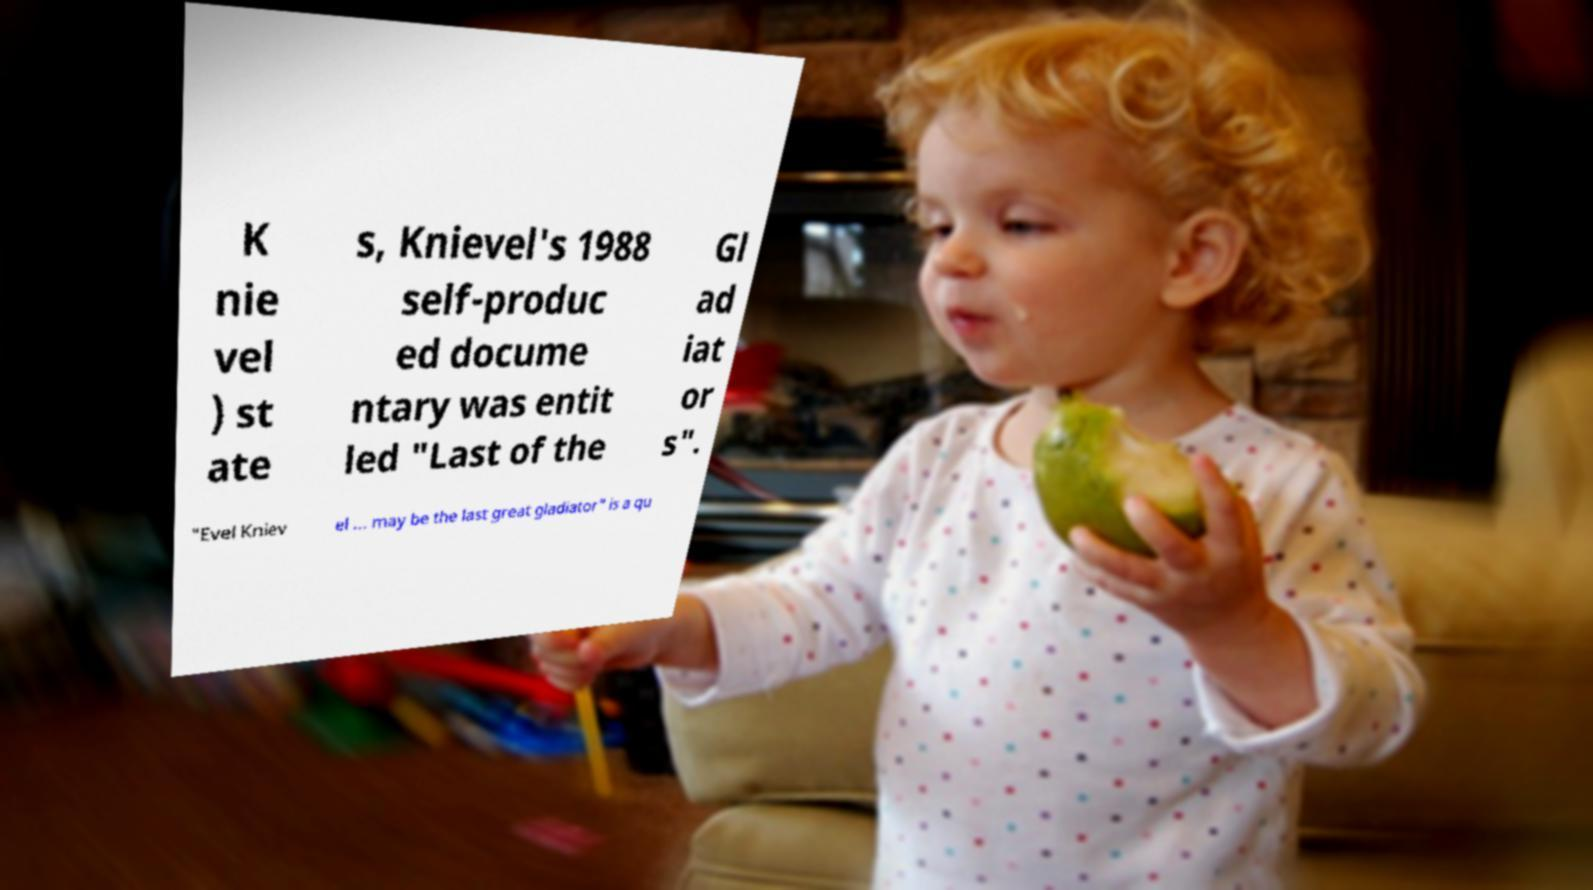For documentation purposes, I need the text within this image transcribed. Could you provide that? K nie vel ) st ate s, Knievel's 1988 self-produc ed docume ntary was entit led "Last of the Gl ad iat or s". "Evel Kniev el ... may be the last great gladiator" is a qu 